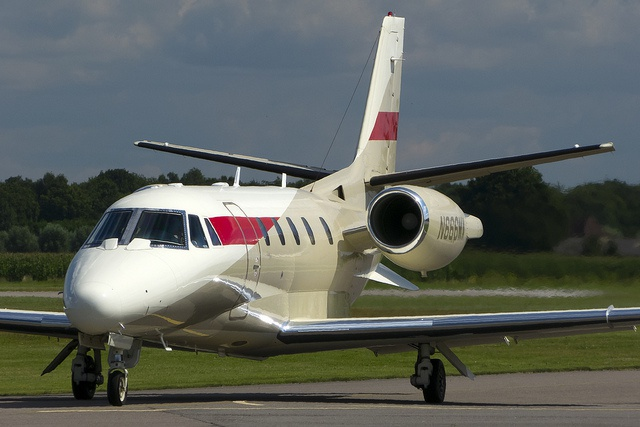Describe the objects in this image and their specific colors. I can see a airplane in gray, black, ivory, and darkgray tones in this image. 